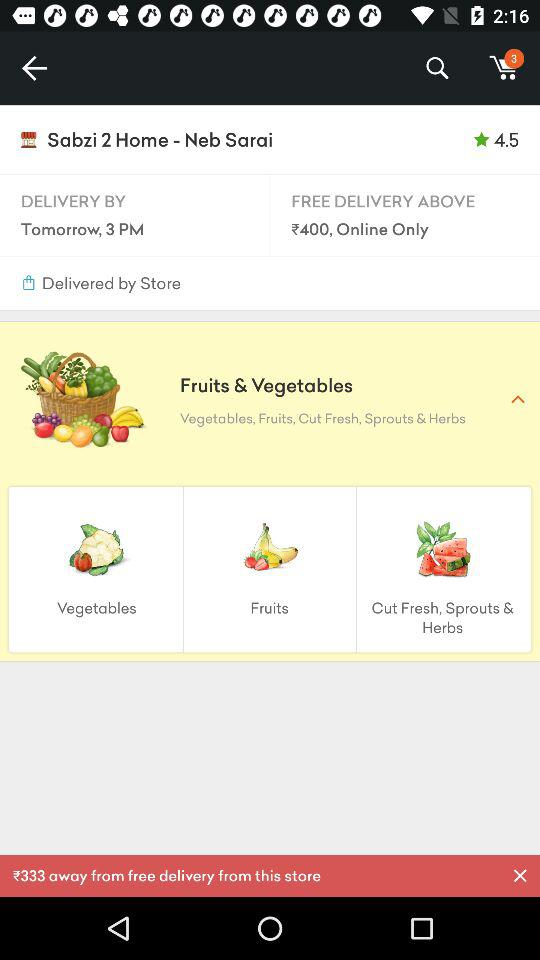What orders are eligible for free delivery? Orders that are above ₹400 ( online only) are eligible for free delivery. 